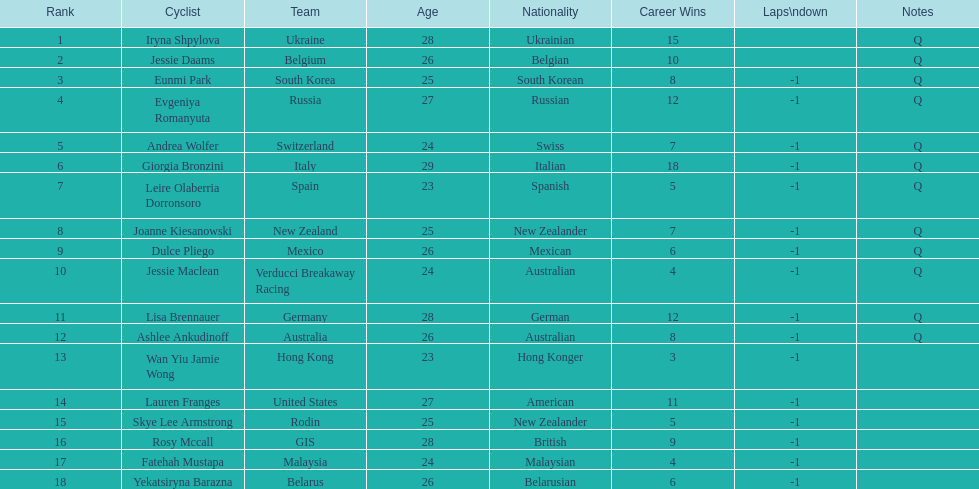How many cyclist are not listed with a country team? 3. 